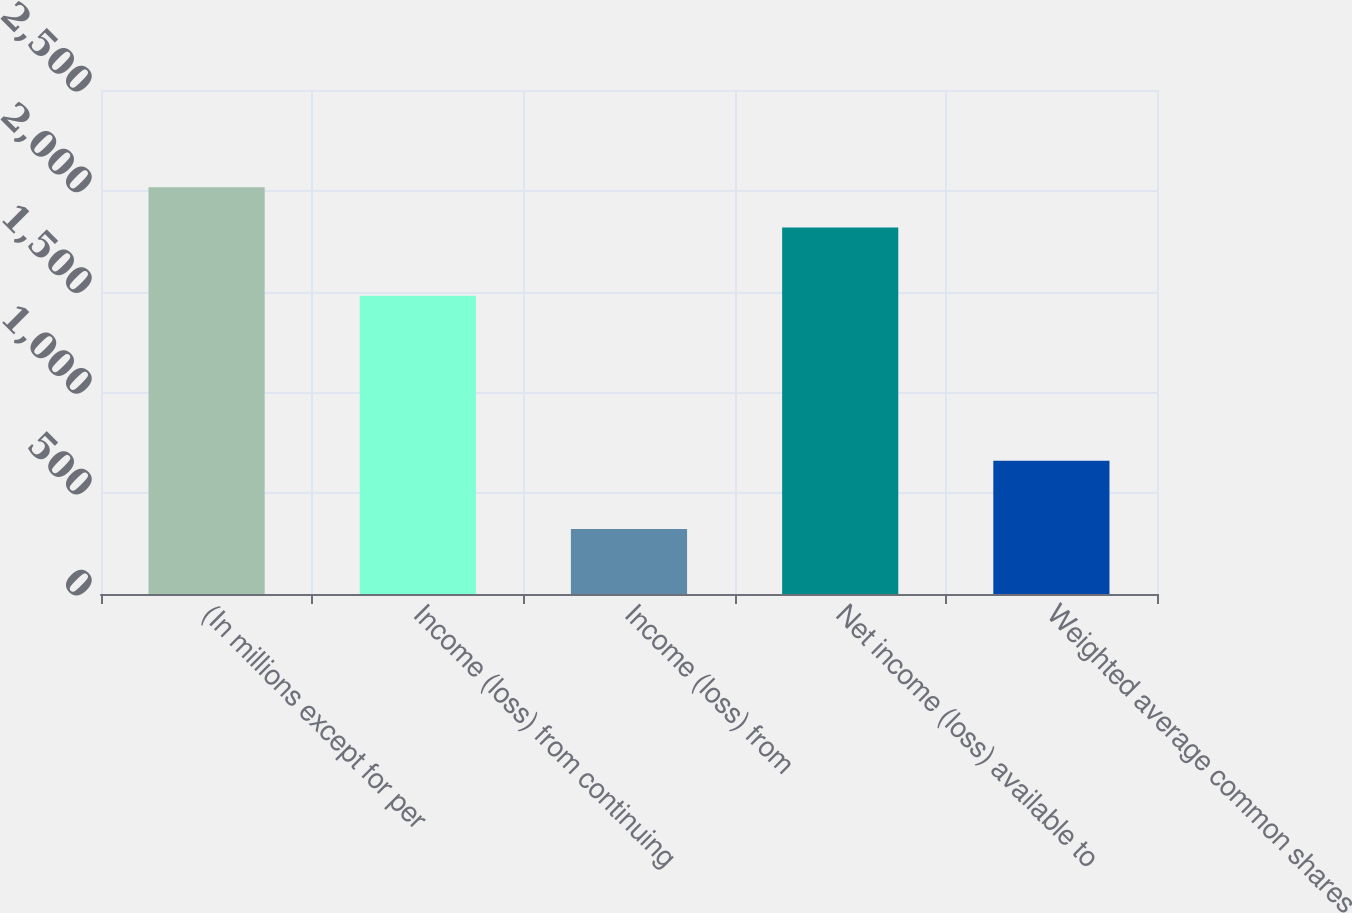<chart> <loc_0><loc_0><loc_500><loc_500><bar_chart><fcel>(In millions except for per<fcel>Income (loss) from continuing<fcel>Income (loss) from<fcel>Net income (loss) available to<fcel>Weighted average common shares<nl><fcel>2018<fcel>1479<fcel>322<fcel>1818.2<fcel>661.2<nl></chart> 